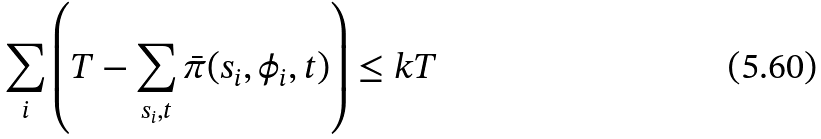Convert formula to latex. <formula><loc_0><loc_0><loc_500><loc_500>\sum _ { i } \left ( T - \sum _ { s _ { i } , t } \bar { \pi } ( s _ { i } , \phi _ { i } , t ) \right ) \leq k T</formula> 